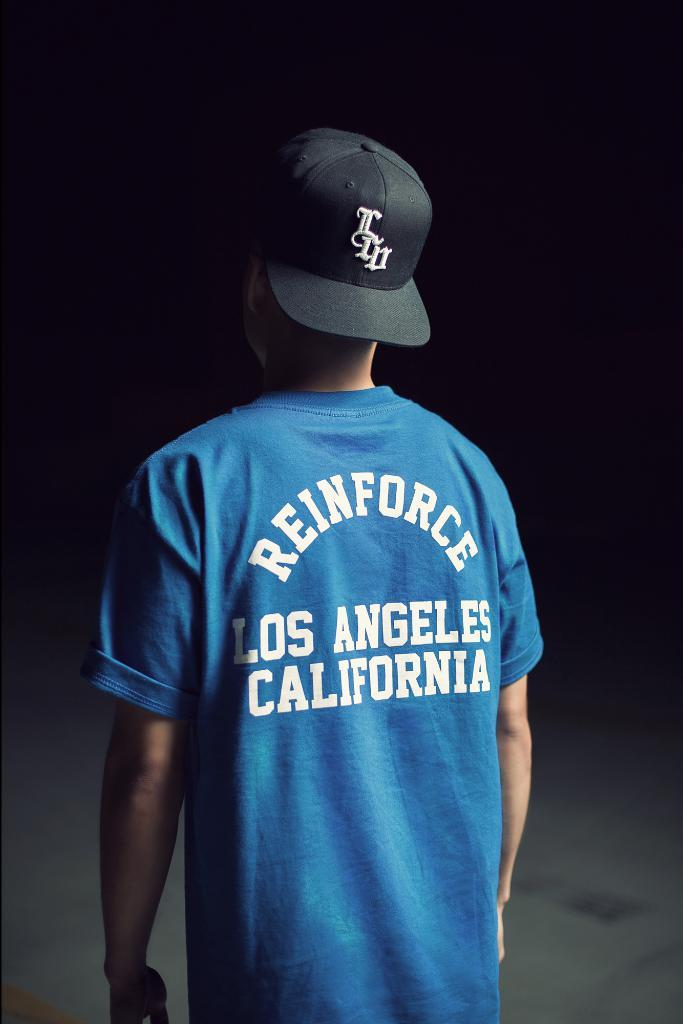<image>
Provide a brief description of the given image. A guy is in a blue shirt with the word reinforce on the back. 